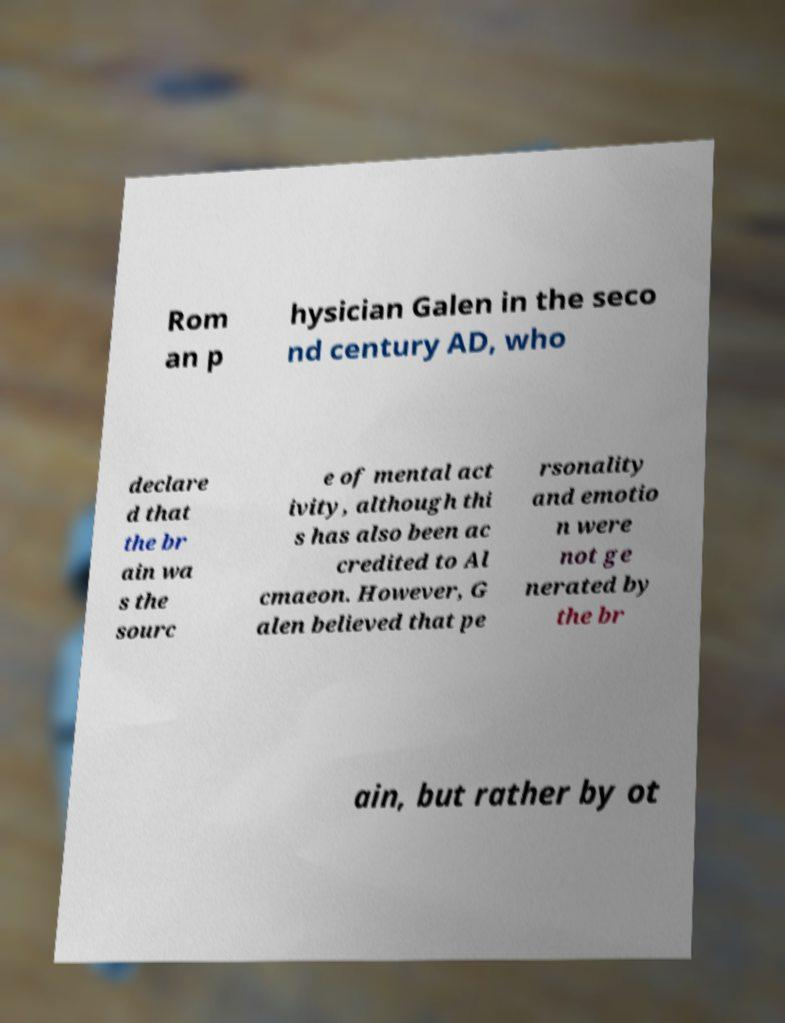Please read and relay the text visible in this image. What does it say? Rom an p hysician Galen in the seco nd century AD, who declare d that the br ain wa s the sourc e of mental act ivity, although thi s has also been ac credited to Al cmaeon. However, G alen believed that pe rsonality and emotio n were not ge nerated by the br ain, but rather by ot 